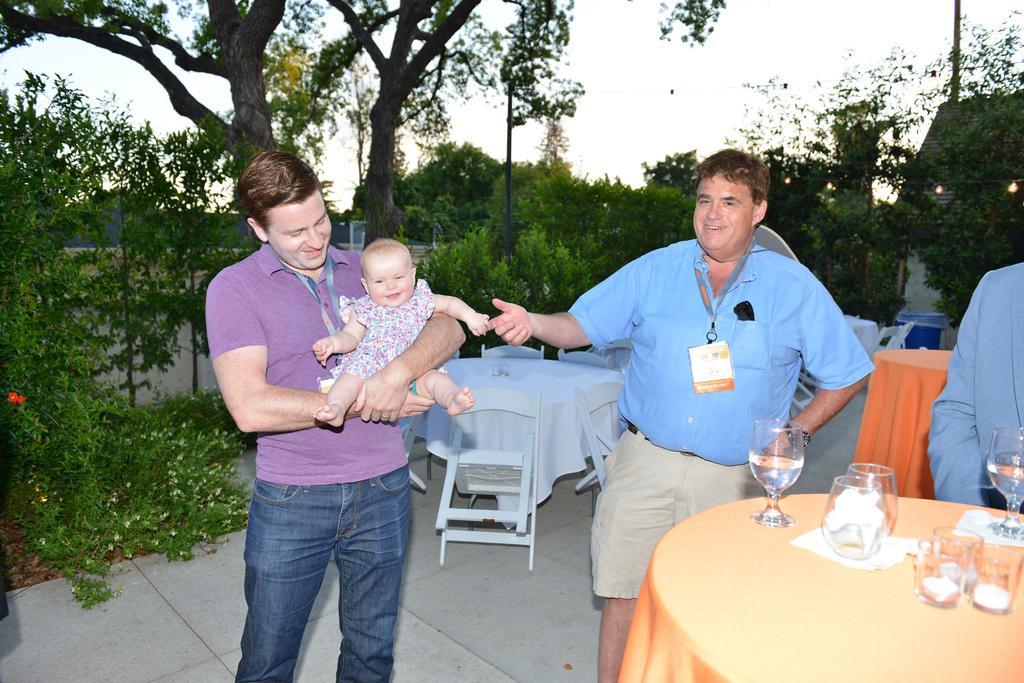In one or two sentences, can you explain what this image depicts? I can see two persons standing,one person is holding a baby girl in his hand. This is a table covered with orange cloth. there are two jugs and tumblers,tissue papers placed on the table. I can see another table covered with white cloth. There are empty white chairs. At background I can see trees and small plants. At the right corner of the image I can see another person standing. 